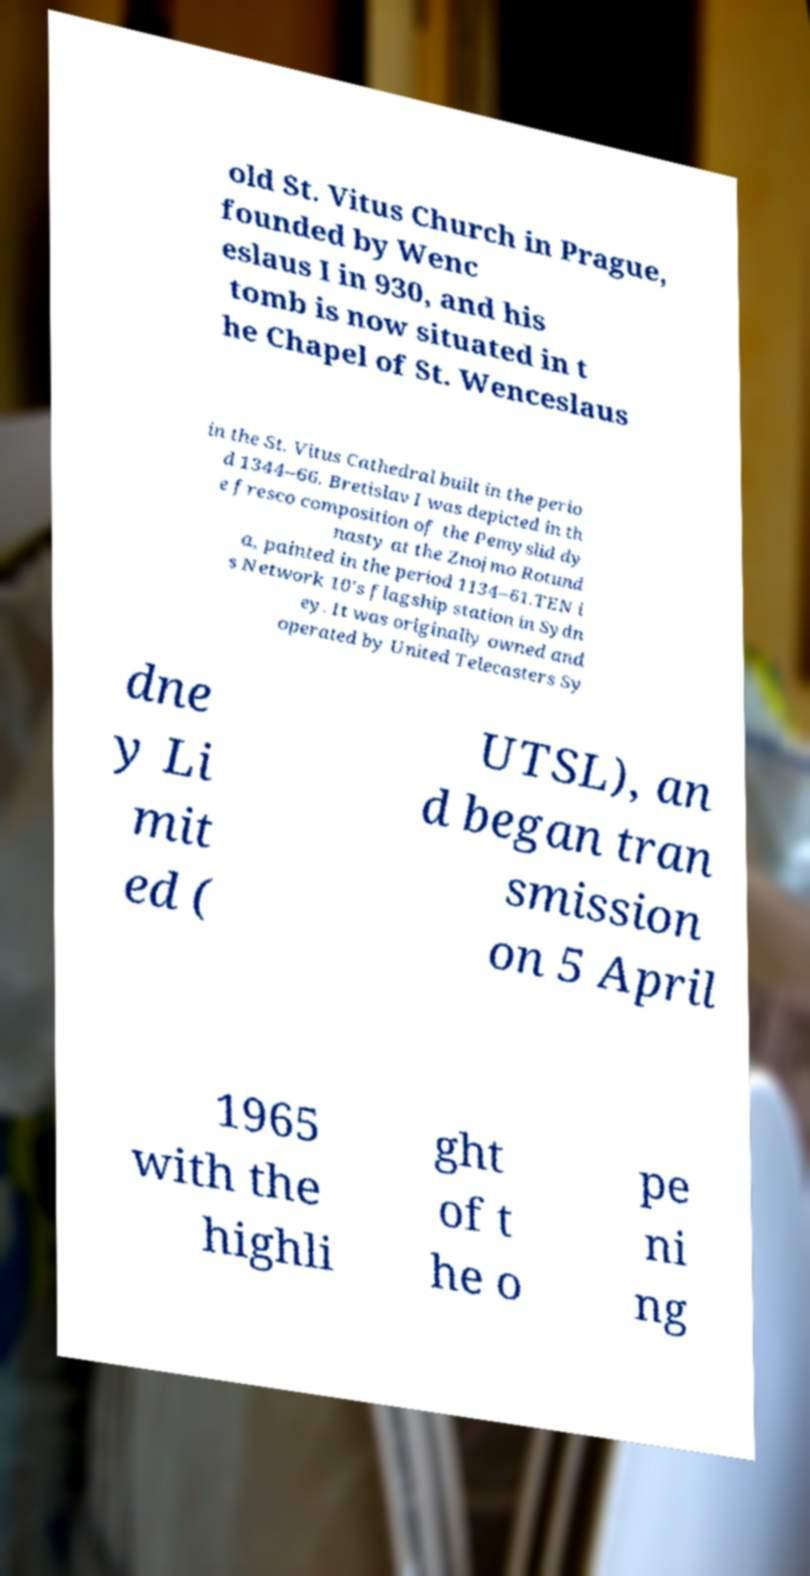There's text embedded in this image that I need extracted. Can you transcribe it verbatim? old St. Vitus Church in Prague, founded by Wenc eslaus I in 930, and his tomb is now situated in t he Chapel of St. Wenceslaus in the St. Vitus Cathedral built in the perio d 1344–66. Bretislav I was depicted in th e fresco composition of the Pemyslid dy nasty at the Znojmo Rotund a, painted in the period 1134–61.TEN i s Network 10's flagship station in Sydn ey. It was originally owned and operated by United Telecasters Sy dne y Li mit ed ( UTSL), an d began tran smission on 5 April 1965 with the highli ght of t he o pe ni ng 